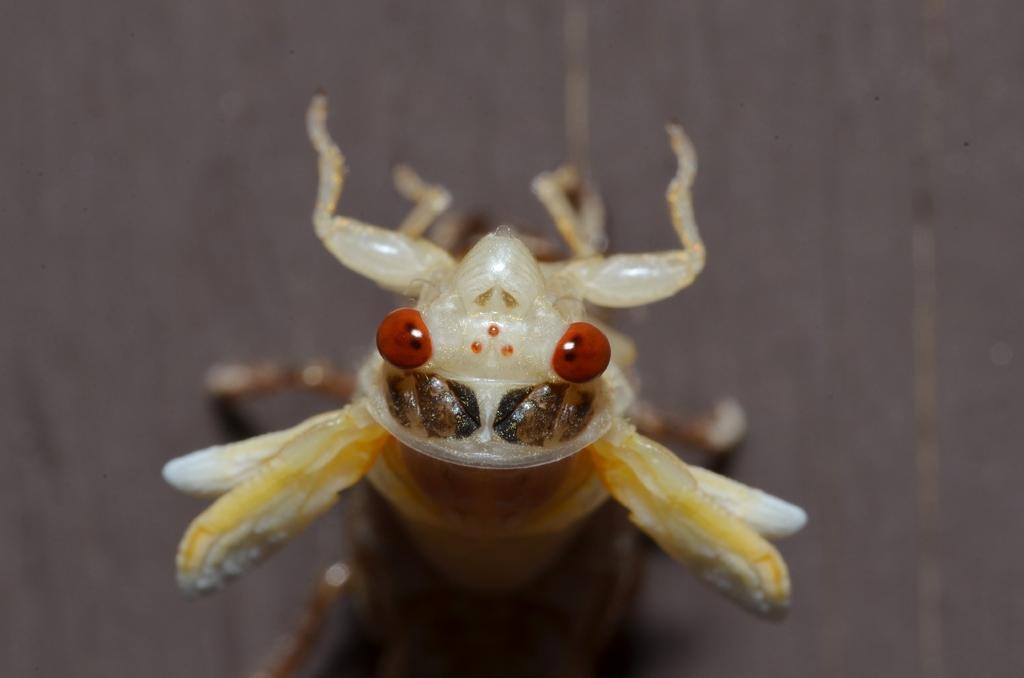Can you describe this image briefly? In this picture I can observe an insect which is in cream color. The background is blurred. 